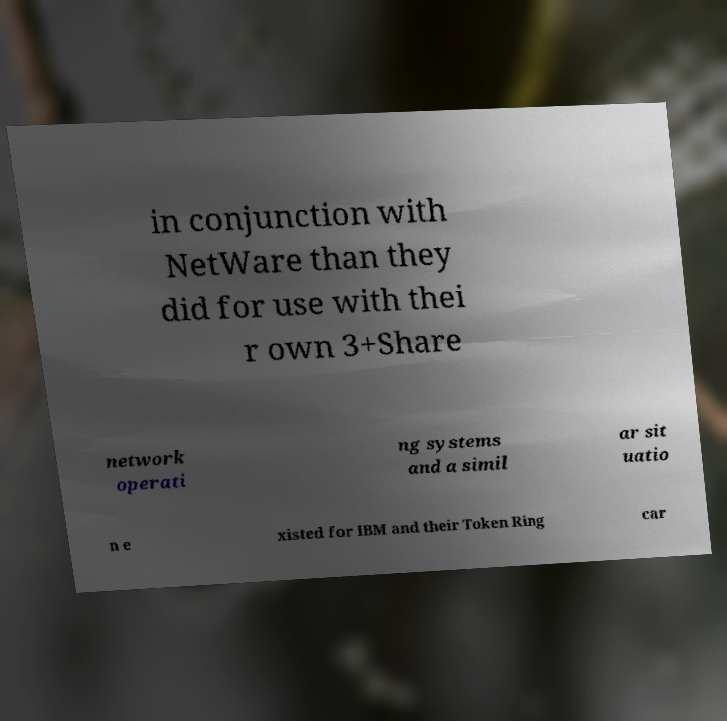Please read and relay the text visible in this image. What does it say? in conjunction with NetWare than they did for use with thei r own 3+Share network operati ng systems and a simil ar sit uatio n e xisted for IBM and their Token Ring car 